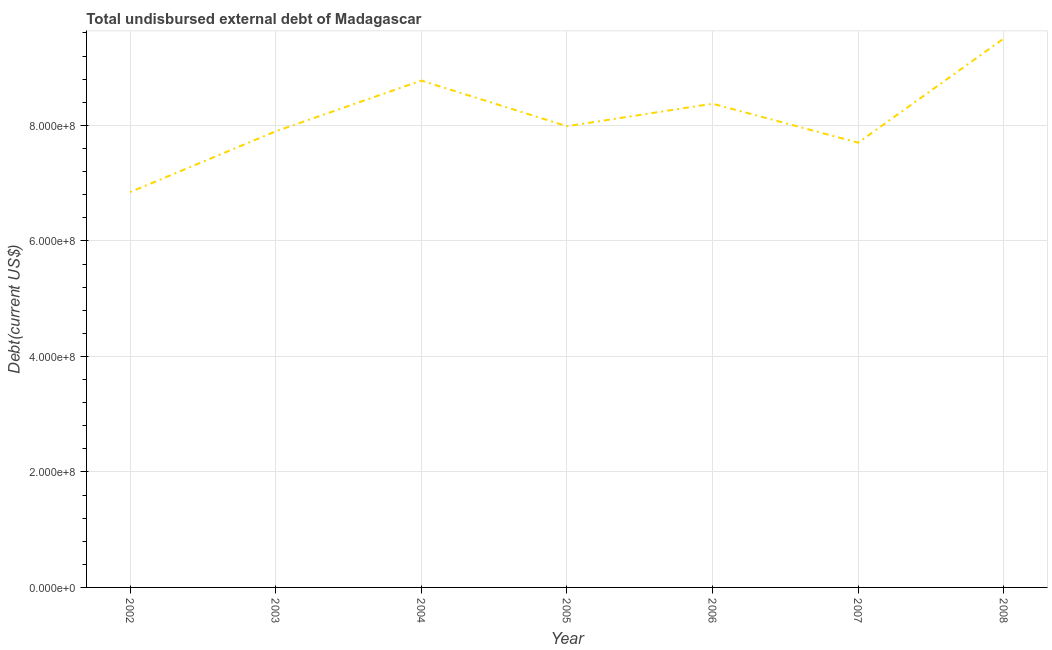What is the total debt in 2003?
Your answer should be very brief. 7.90e+08. Across all years, what is the maximum total debt?
Your answer should be very brief. 9.50e+08. Across all years, what is the minimum total debt?
Provide a succinct answer. 6.84e+08. In which year was the total debt minimum?
Your answer should be compact. 2002. What is the sum of the total debt?
Make the answer very short. 5.71e+09. What is the difference between the total debt in 2004 and 2006?
Your response must be concise. 4.00e+07. What is the average total debt per year?
Provide a succinct answer. 8.15e+08. What is the median total debt?
Give a very brief answer. 7.99e+08. In how many years, is the total debt greater than 840000000 US$?
Ensure brevity in your answer.  2. What is the ratio of the total debt in 2003 to that in 2007?
Provide a short and direct response. 1.03. Is the difference between the total debt in 2002 and 2005 greater than the difference between any two years?
Offer a terse response. No. What is the difference between the highest and the second highest total debt?
Your answer should be compact. 7.29e+07. What is the difference between the highest and the lowest total debt?
Offer a terse response. 2.66e+08. Does the total debt monotonically increase over the years?
Your response must be concise. No. How many lines are there?
Your answer should be very brief. 1. How many years are there in the graph?
Give a very brief answer. 7. What is the difference between two consecutive major ticks on the Y-axis?
Ensure brevity in your answer.  2.00e+08. Does the graph contain any zero values?
Your answer should be very brief. No. Does the graph contain grids?
Your answer should be compact. Yes. What is the title of the graph?
Make the answer very short. Total undisbursed external debt of Madagascar. What is the label or title of the X-axis?
Offer a very short reply. Year. What is the label or title of the Y-axis?
Give a very brief answer. Debt(current US$). What is the Debt(current US$) in 2002?
Provide a succinct answer. 6.84e+08. What is the Debt(current US$) of 2003?
Make the answer very short. 7.90e+08. What is the Debt(current US$) of 2004?
Your answer should be very brief. 8.78e+08. What is the Debt(current US$) of 2005?
Your answer should be compact. 7.99e+08. What is the Debt(current US$) in 2006?
Provide a short and direct response. 8.38e+08. What is the Debt(current US$) of 2007?
Your answer should be very brief. 7.70e+08. What is the Debt(current US$) of 2008?
Your answer should be very brief. 9.50e+08. What is the difference between the Debt(current US$) in 2002 and 2003?
Provide a succinct answer. -1.05e+08. What is the difference between the Debt(current US$) in 2002 and 2004?
Give a very brief answer. -1.93e+08. What is the difference between the Debt(current US$) in 2002 and 2005?
Offer a terse response. -1.14e+08. What is the difference between the Debt(current US$) in 2002 and 2006?
Offer a very short reply. -1.53e+08. What is the difference between the Debt(current US$) in 2002 and 2007?
Make the answer very short. -8.56e+07. What is the difference between the Debt(current US$) in 2002 and 2008?
Make the answer very short. -2.66e+08. What is the difference between the Debt(current US$) in 2003 and 2004?
Offer a very short reply. -8.78e+07. What is the difference between the Debt(current US$) in 2003 and 2005?
Give a very brief answer. -8.80e+06. What is the difference between the Debt(current US$) in 2003 and 2006?
Your answer should be very brief. -4.78e+07. What is the difference between the Debt(current US$) in 2003 and 2007?
Your answer should be compact. 1.97e+07. What is the difference between the Debt(current US$) in 2003 and 2008?
Give a very brief answer. -1.61e+08. What is the difference between the Debt(current US$) in 2004 and 2005?
Offer a terse response. 7.90e+07. What is the difference between the Debt(current US$) in 2004 and 2006?
Your answer should be compact. 4.00e+07. What is the difference between the Debt(current US$) in 2004 and 2007?
Offer a terse response. 1.08e+08. What is the difference between the Debt(current US$) in 2004 and 2008?
Ensure brevity in your answer.  -7.29e+07. What is the difference between the Debt(current US$) in 2005 and 2006?
Provide a short and direct response. -3.90e+07. What is the difference between the Debt(current US$) in 2005 and 2007?
Provide a succinct answer. 2.85e+07. What is the difference between the Debt(current US$) in 2005 and 2008?
Ensure brevity in your answer.  -1.52e+08. What is the difference between the Debt(current US$) in 2006 and 2007?
Your response must be concise. 6.75e+07. What is the difference between the Debt(current US$) in 2006 and 2008?
Your response must be concise. -1.13e+08. What is the difference between the Debt(current US$) in 2007 and 2008?
Keep it short and to the point. -1.80e+08. What is the ratio of the Debt(current US$) in 2002 to that in 2003?
Your answer should be compact. 0.87. What is the ratio of the Debt(current US$) in 2002 to that in 2004?
Your answer should be compact. 0.78. What is the ratio of the Debt(current US$) in 2002 to that in 2005?
Keep it short and to the point. 0.86. What is the ratio of the Debt(current US$) in 2002 to that in 2006?
Ensure brevity in your answer.  0.82. What is the ratio of the Debt(current US$) in 2002 to that in 2007?
Your answer should be very brief. 0.89. What is the ratio of the Debt(current US$) in 2002 to that in 2008?
Your answer should be compact. 0.72. What is the ratio of the Debt(current US$) in 2003 to that in 2006?
Make the answer very short. 0.94. What is the ratio of the Debt(current US$) in 2003 to that in 2007?
Provide a succinct answer. 1.03. What is the ratio of the Debt(current US$) in 2003 to that in 2008?
Keep it short and to the point. 0.83. What is the ratio of the Debt(current US$) in 2004 to that in 2005?
Offer a very short reply. 1.1. What is the ratio of the Debt(current US$) in 2004 to that in 2006?
Provide a succinct answer. 1.05. What is the ratio of the Debt(current US$) in 2004 to that in 2007?
Your answer should be very brief. 1.14. What is the ratio of the Debt(current US$) in 2004 to that in 2008?
Offer a very short reply. 0.92. What is the ratio of the Debt(current US$) in 2005 to that in 2006?
Provide a short and direct response. 0.95. What is the ratio of the Debt(current US$) in 2005 to that in 2007?
Ensure brevity in your answer.  1.04. What is the ratio of the Debt(current US$) in 2005 to that in 2008?
Ensure brevity in your answer.  0.84. What is the ratio of the Debt(current US$) in 2006 to that in 2007?
Give a very brief answer. 1.09. What is the ratio of the Debt(current US$) in 2006 to that in 2008?
Ensure brevity in your answer.  0.88. What is the ratio of the Debt(current US$) in 2007 to that in 2008?
Give a very brief answer. 0.81. 